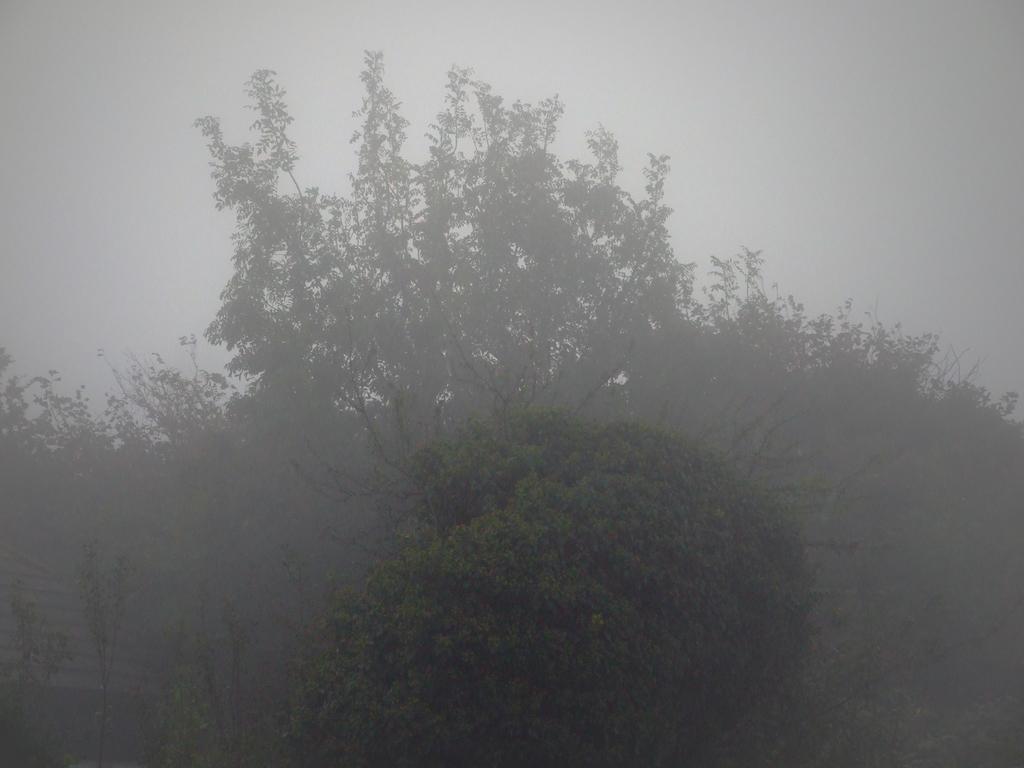Can you describe this image briefly? In this picture we can see few trees. 